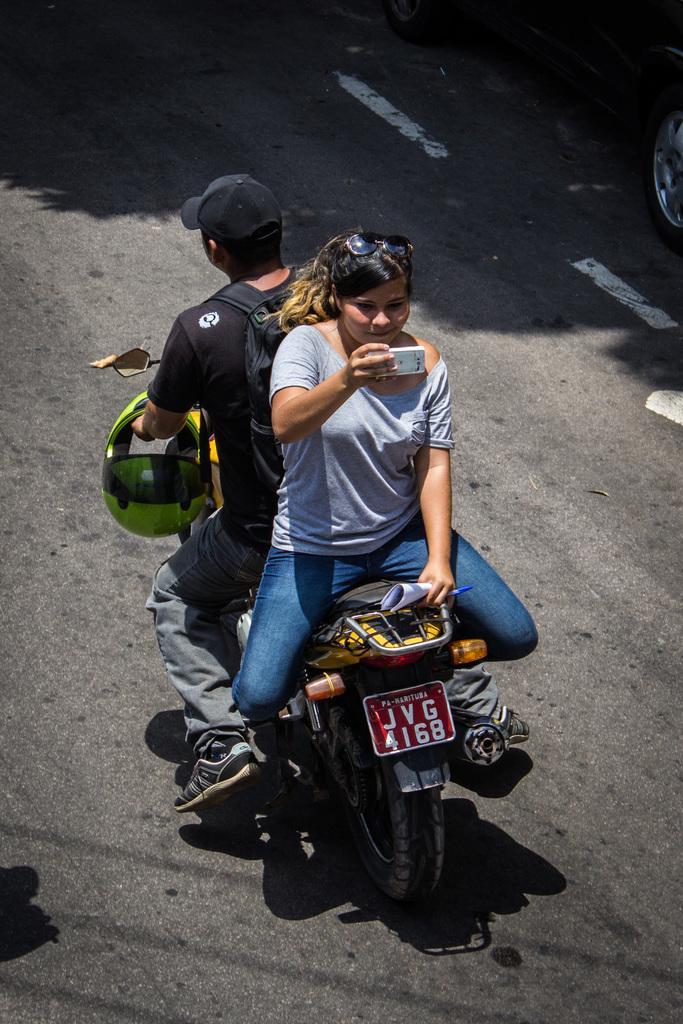In one or two sentences, can you explain what this image depicts? This 2 persons are highlighted in this picture. This 2 persons are sitting on a motorbike. This man is holding a helmet and wire bag. This woman is holding a mobile and papers. 